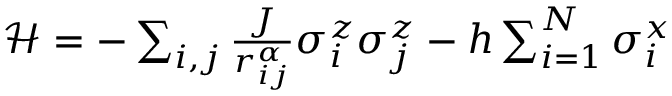Convert formula to latex. <formula><loc_0><loc_0><loc_500><loc_500>\begin{array} { r } { \mathcal { H } = - \sum _ { i , j } \frac { J } { r _ { i j } ^ { \alpha } } \sigma _ { i } ^ { z } \sigma _ { j } ^ { z } - h \sum _ { i = 1 } ^ { N } \sigma _ { i } ^ { x } } \end{array}</formula> 